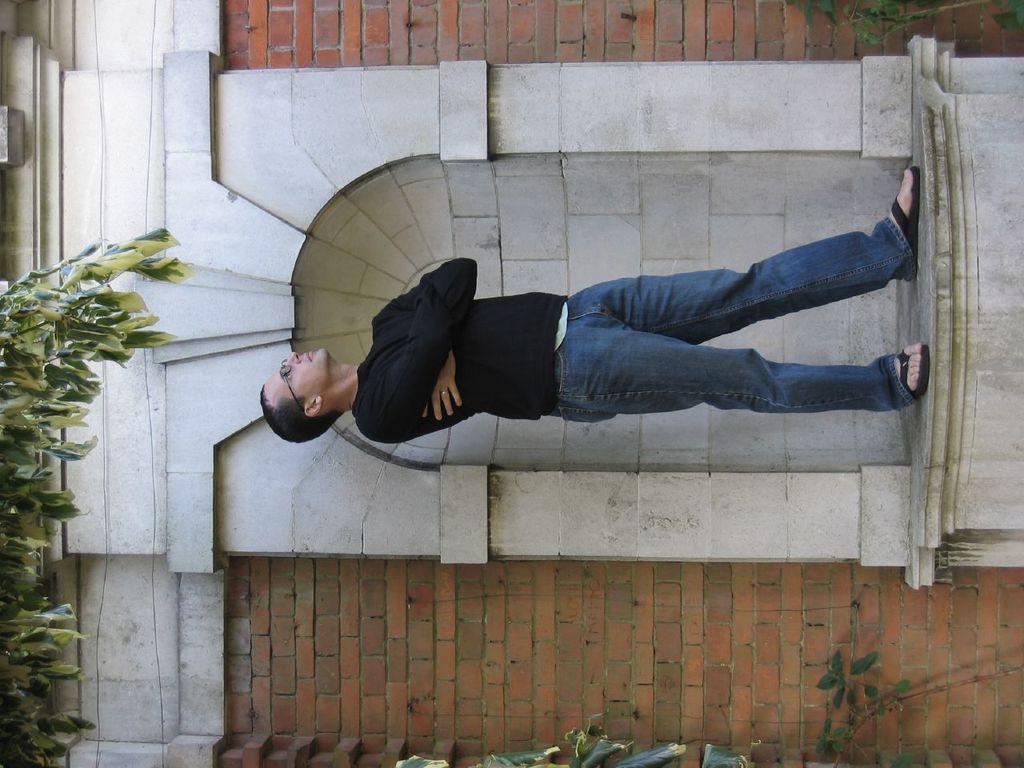Could you give a brief overview of what you see in this image? This picture is in leftward direction. In the center, there is a man standing on the stone. He is wearing a black t shirt and blue jeans. Behind him, there is a wall with bricks. Towards the left corner, there are leaves. At the bottom, there are plants. 